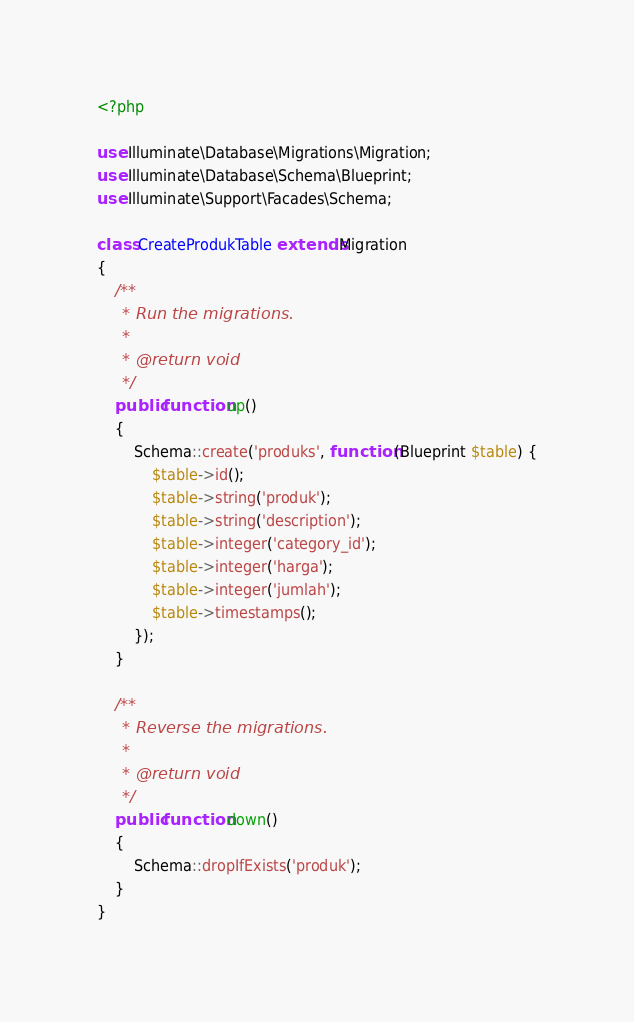<code> <loc_0><loc_0><loc_500><loc_500><_PHP_><?php

use Illuminate\Database\Migrations\Migration;
use Illuminate\Database\Schema\Blueprint;
use Illuminate\Support\Facades\Schema;

class CreateProdukTable extends Migration
{
    /**
     * Run the migrations.
     *
     * @return void
     */
    public function up()
    {
        Schema::create('produks', function (Blueprint $table) {
            $table->id();
            $table->string('produk');
            $table->string('description');
            $table->integer('category_id');
            $table->integer('harga');
            $table->integer('jumlah');
            $table->timestamps();
        });
    }

    /**
     * Reverse the migrations.
     *
     * @return void
     */
    public function down()
    {
        Schema::dropIfExists('produk');
    }
}
</code> 